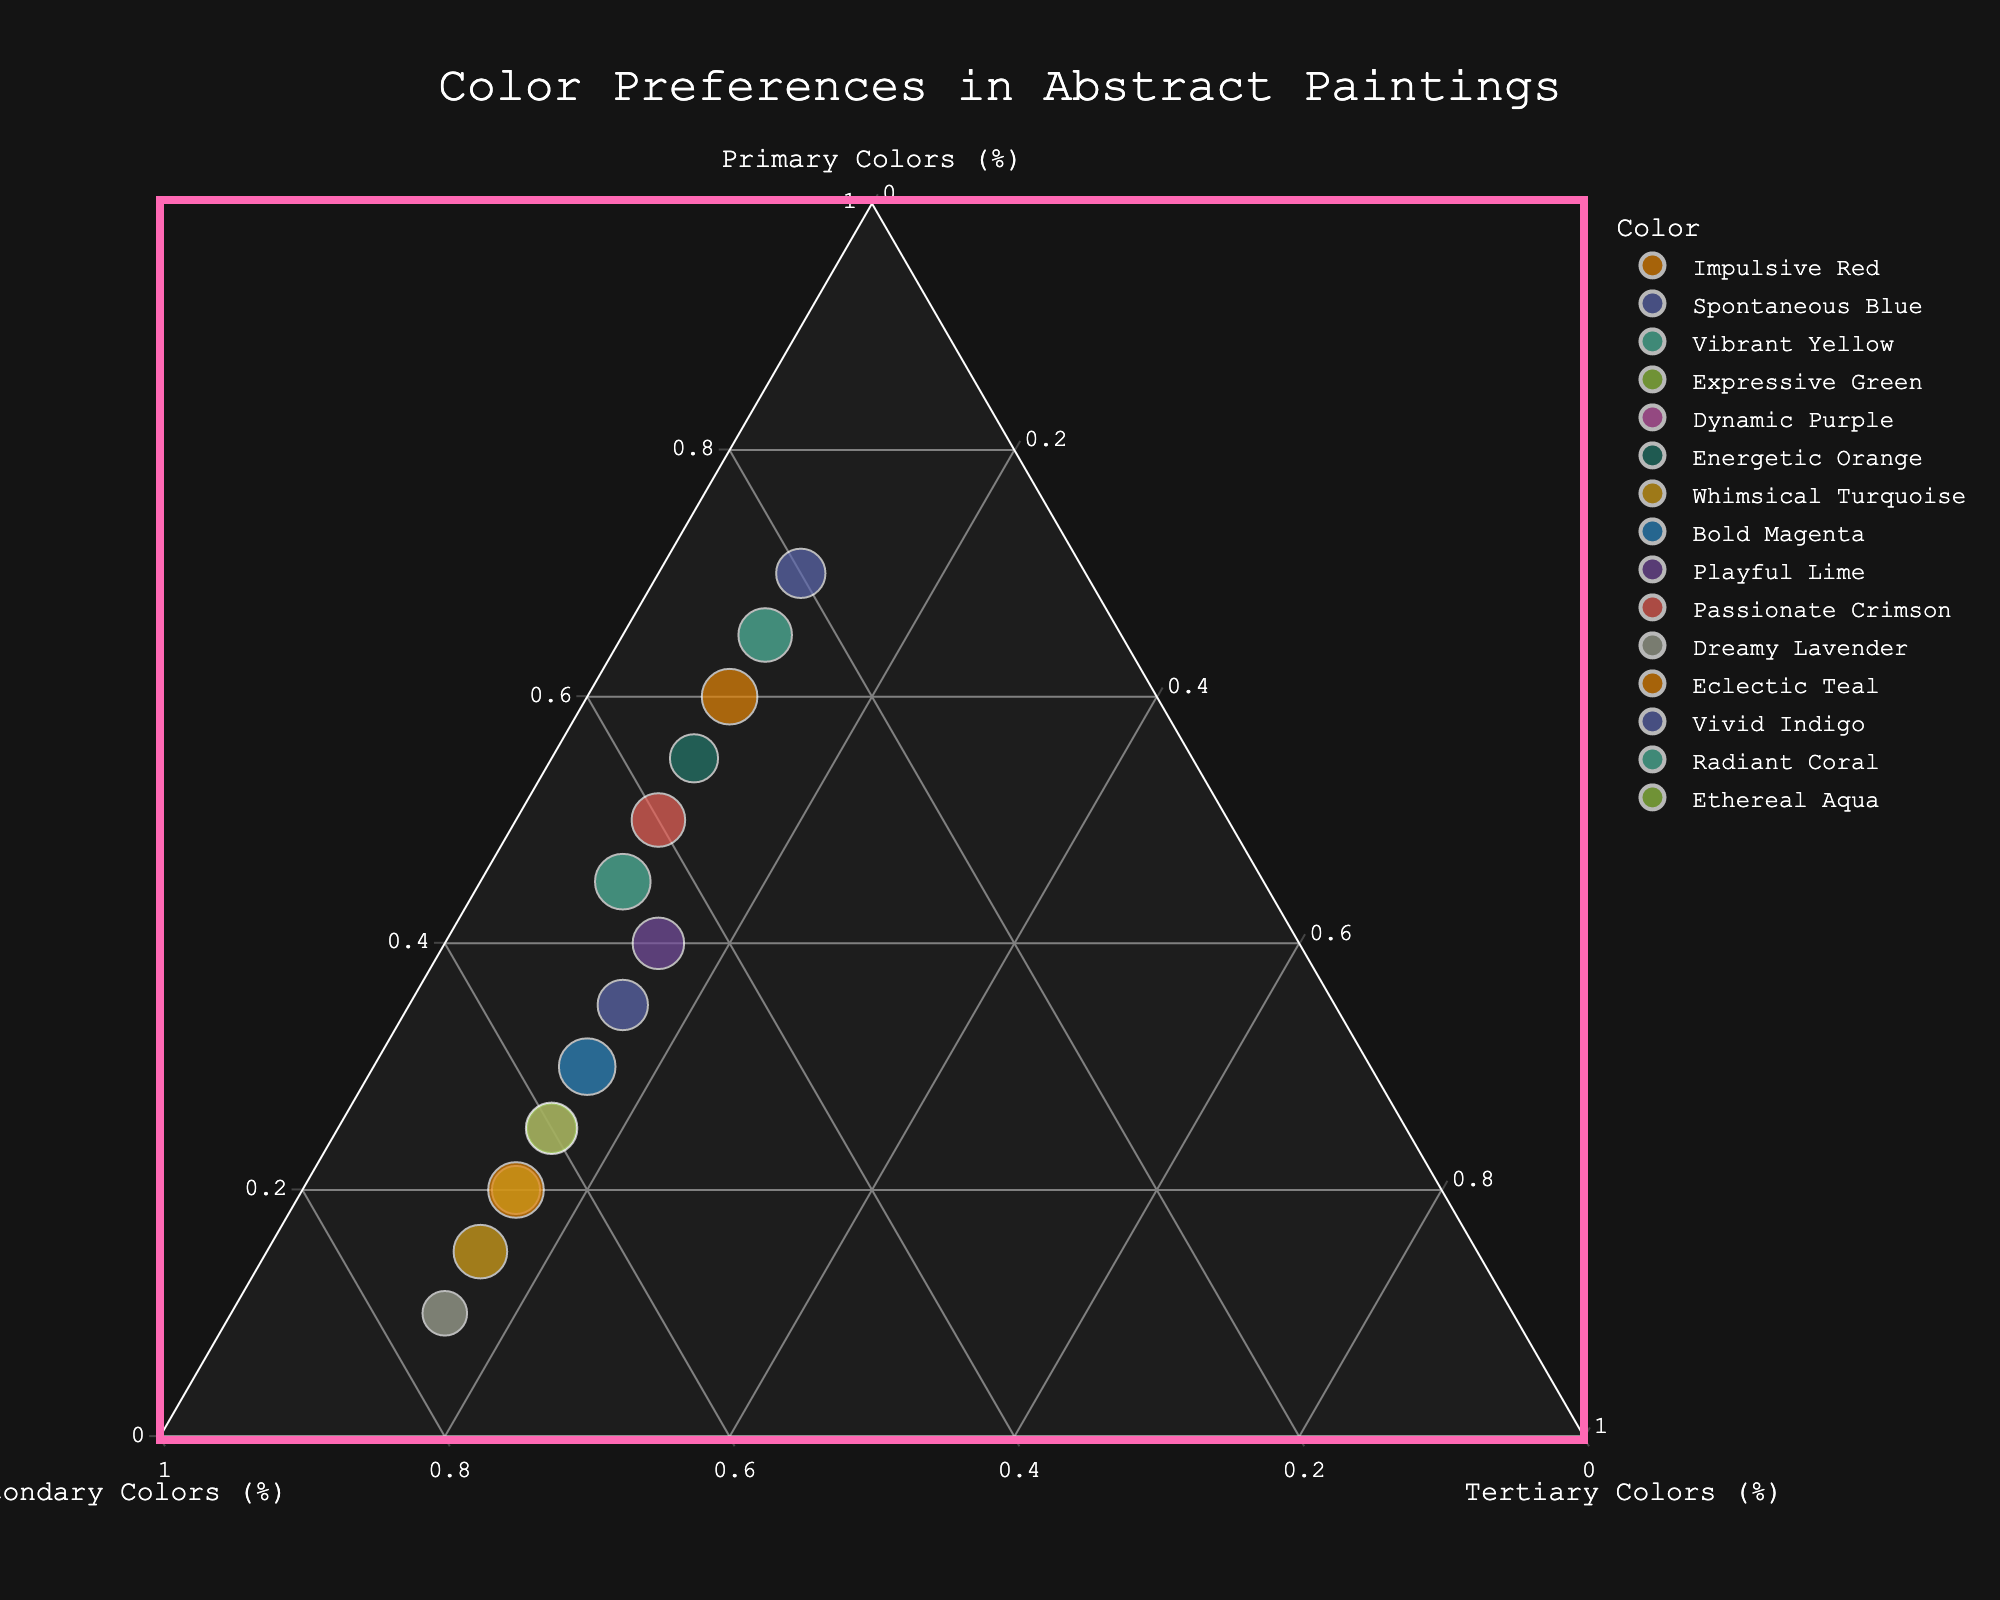How many colors exhibit more dominance of primary colors over secondary and tertiary? To determine this, identify data points where the percentage of primary colors is higher than both secondary and tertiary colors. Colors: Impulsive Red, Spontaneous Blue, Vibrant Yellow, and Energetic Orange.
Answer: 4 Which color has the highest proportion of secondary colors? Check the data points for the maximum percentage value in the Secondary column. Dreamy Lavender has the highest proportion of secondary colors at 75%.
Answer: Dreamy Lavender What is the average percentage of tertiary colors across all color preferences? Sum the Tertiary percentages of all entries (10+10+10+15+15+10+15+15+15+10+15+15+15+10+15) = 190, then divide by the number of entries (15). Average = 190/15 = 12.67%.
Answer: 12.67% Which color is closest to having an equal percentage of primary and secondary colors? Look for a color where the difference between the primary and secondary percentages is the smallest. Playful Lime has 40% primary and 45% secondary, the smallest difference (5%).
Answer: Playful Lime Compare the spread of primary colors in the dataset. What is the range? Identify the minimum and maximum values in the Primary column. Minimum: 10 (Dreamy Lavender), Maximum: 70 (Spontaneous Blue). Range = 70 - 10 = 60.
Answer: 60 Which colors show exactly the same proportions of tertiary colors? Identify data points where the Tertiary percentages are identical. Colors with 15% tertiary are Expressive Green, Dynamic Purple, Whimsical Turquoise, Bold Magenta, Playful Lime, Dreamy Lavender, Eclectic Teal, Vivid Indigo, Ethereal Aqua.
Answer: 9 Is there any color with an equal proportion of all three types of colors? Check the data points to see if any have equal percentages for Primary, Secondary, and Tertiary. No color has equal proportions across all three.
Answer: None What is the total percentage of secondary colors in colors where the primary color percentage is below 40? Sum secondary percentages only for colors where Primary < 40 (Expressive Green, Dynamic Purple, Whimsical Turquoise, Bold Magenta, Dreamy Lavender, Eclectic Teal, Ethereal Aqua). Sum: 65+60+70+55+75+65+60 = 450.
Answer: 450 Which color has the smallest proportion of primary colors, and what is that proportion? Identify the data point with the lowest percentage in the Primary column. Dreamy Lavender has the smallest proportion with 10%.
Answer: Dreamy Lavender Which two colors are closest in their proportions of primary and secondary colors? Look for pairs of data points where the difference in both Primary and Secondary percentages is the smallest. Bold Magenta and Ethereal Aqua, both having Primary 30% vs 25% and Secondary 55% vs 60%, show the smallest differences.
Answer: Bold Magenta and Ethereal Aqua 